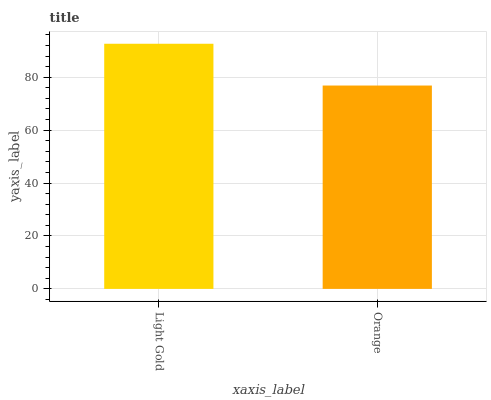Is Orange the minimum?
Answer yes or no. Yes. Is Light Gold the maximum?
Answer yes or no. Yes. Is Orange the maximum?
Answer yes or no. No. Is Light Gold greater than Orange?
Answer yes or no. Yes. Is Orange less than Light Gold?
Answer yes or no. Yes. Is Orange greater than Light Gold?
Answer yes or no. No. Is Light Gold less than Orange?
Answer yes or no. No. Is Light Gold the high median?
Answer yes or no. Yes. Is Orange the low median?
Answer yes or no. Yes. Is Orange the high median?
Answer yes or no. No. Is Light Gold the low median?
Answer yes or no. No. 